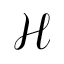Convert formula to latex. <formula><loc_0><loc_0><loc_500><loc_500>\mathcal { H }</formula> 